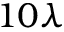<formula> <loc_0><loc_0><loc_500><loc_500>1 0 \lambda</formula> 